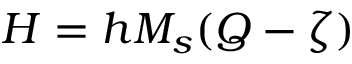<formula> <loc_0><loc_0><loc_500><loc_500>H = h M _ { s } ( Q - \zeta )</formula> 